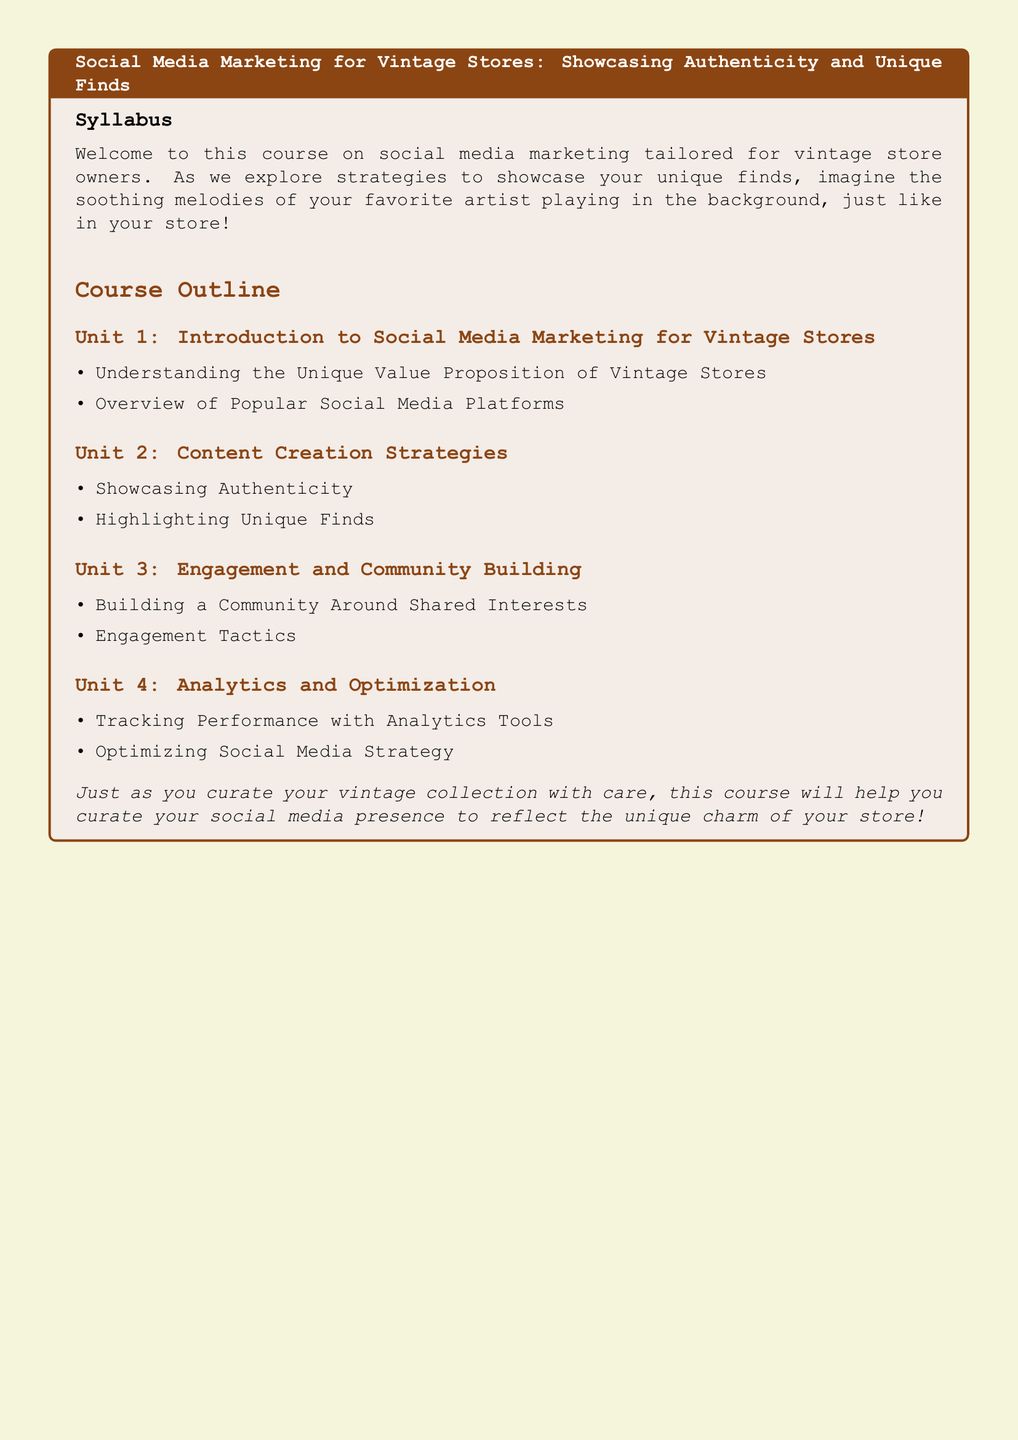What is the title of the syllabus? The title is provided prominently at the top of the syllabus.
Answer: Social Media Marketing for Vintage Stores: Showcasing Authenticity and Unique Finds What is the first unit in the course outline? The first unit is listed under the course outline section.
Answer: Introduction to Social Media Marketing for Vintage Stores How many units are included in the course outline? The total number of units outlined within the document is counted.
Answer: Four What is one content creation strategy mentioned? The unit lists two content creation strategies as bullet points.
Answer: Showcasing Authenticity What is a key focus in the engagement and community building unit? The second item listed in this unit provides insight into community engagement tactics.
Answer: Engagement Tactics What is the final objective of the course compared to? The final statement in the syllabus provides a metaphor as a culmination of the course's purpose.
Answer: Curate your social media presence What type of tools are mentioned for tracking performance? The syllabus specifies the type of tools used within the analytics unit.
Answer: Analytics Tools What is the color theme used in the syllabus background? The background color for the entire document is defined at the top.
Answer: Vintage beige 